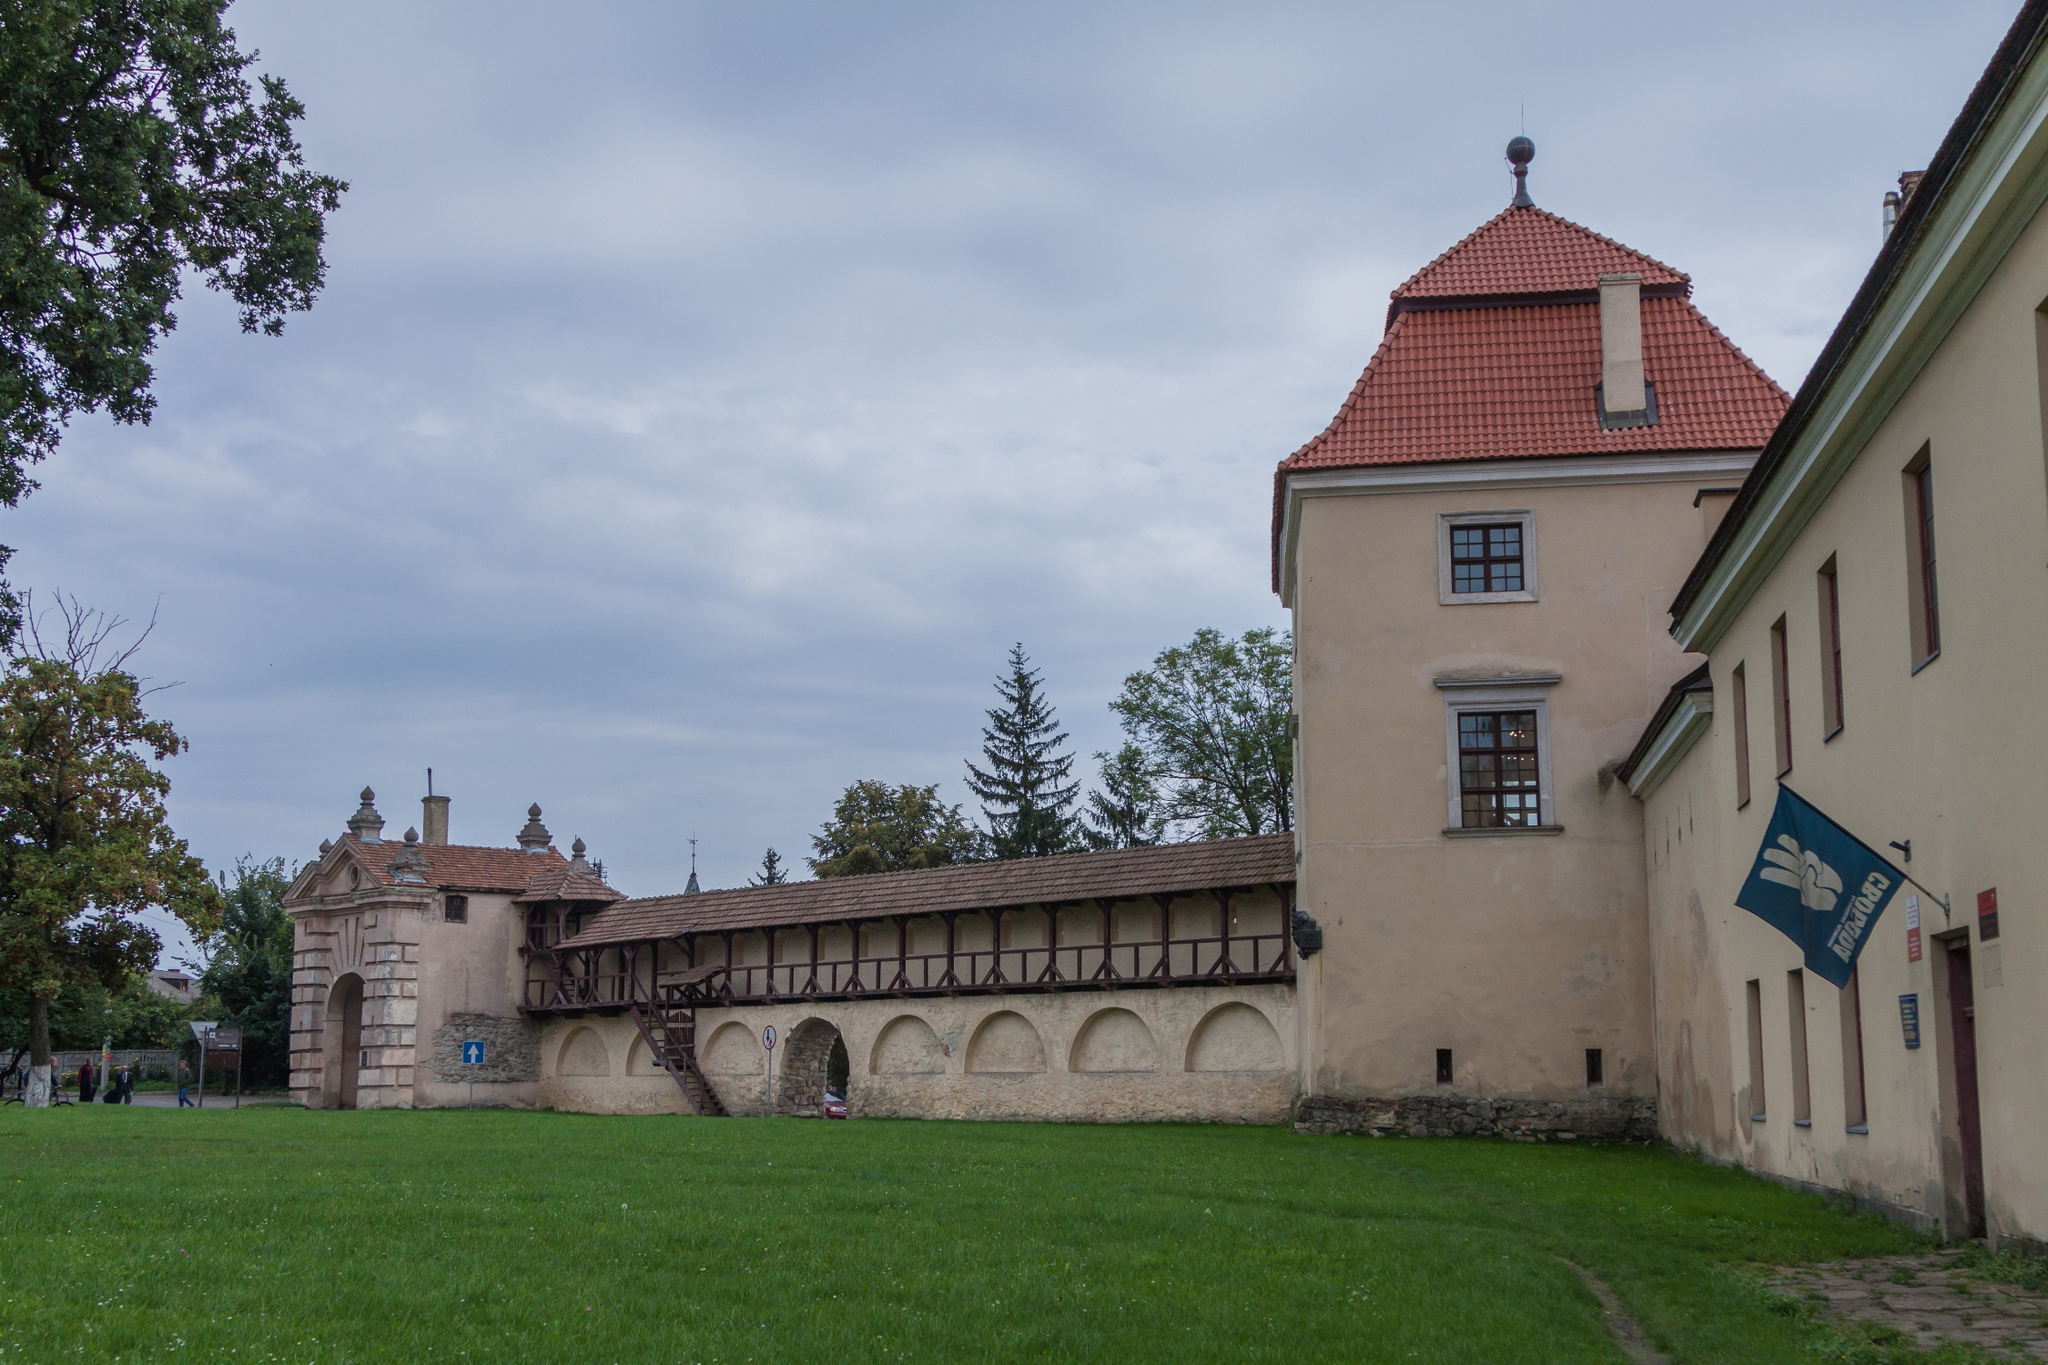What do you see happening in this image? The image captures a charming historic building set within a peaceful, park-like environment. The building, featuring a traditional red-tiled roof and an elevated wooden walkway, exudes an ancient and majestic aura. It's gracefully enveloped by lush greenery including trees and a well-maintained grass lawn, which adds to the tranquility of the scene. The overcast sky casts a gentle, diffused light over the area, contributing to a serene ambiance. The perspective, angled slightly upwards from the ground level, makes the structure appear even more grandiose and imposing. Notably, there is a blue sign on the right side of the image with white lettering that appears to indicate the building's landmark status, labeled 'sa_11107'—potentially a code or identifier. This picturesque setting hints that the building could be of historic significance, possibly serving as a museum, a preserved heritage site, or a noteworthy institution. 